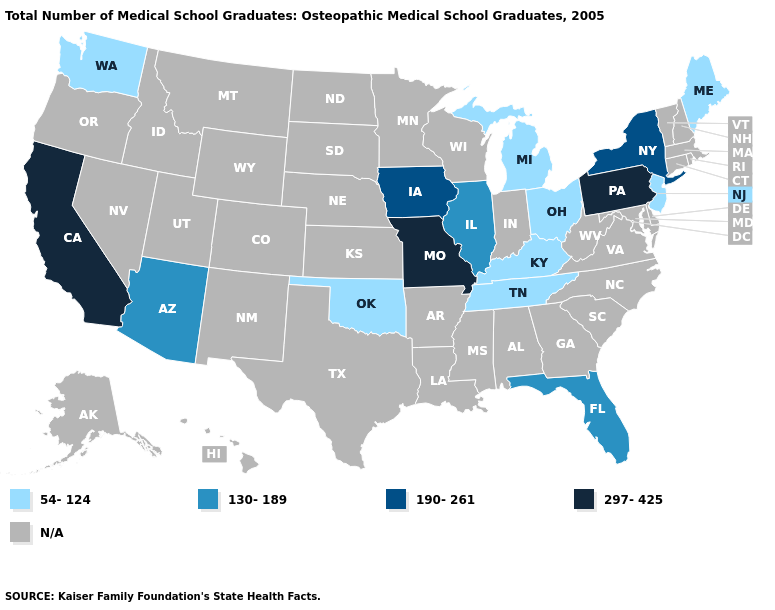Does Maine have the lowest value in the Northeast?
Short answer required. Yes. What is the value of Washington?
Quick response, please. 54-124. What is the value of South Dakota?
Be succinct. N/A. What is the value of Nevada?
Keep it brief. N/A. What is the value of Montana?
Keep it brief. N/A. Is the legend a continuous bar?
Give a very brief answer. No. Name the states that have a value in the range 130-189?
Short answer required. Arizona, Florida, Illinois. Does New York have the highest value in the USA?
Quick response, please. No. Does the first symbol in the legend represent the smallest category?
Write a very short answer. Yes. Name the states that have a value in the range 297-425?
Give a very brief answer. California, Missouri, Pennsylvania. Which states have the highest value in the USA?
Be succinct. California, Missouri, Pennsylvania. What is the value of New York?
Be succinct. 190-261. Name the states that have a value in the range N/A?
Short answer required. Alabama, Alaska, Arkansas, Colorado, Connecticut, Delaware, Georgia, Hawaii, Idaho, Indiana, Kansas, Louisiana, Maryland, Massachusetts, Minnesota, Mississippi, Montana, Nebraska, Nevada, New Hampshire, New Mexico, North Carolina, North Dakota, Oregon, Rhode Island, South Carolina, South Dakota, Texas, Utah, Vermont, Virginia, West Virginia, Wisconsin, Wyoming. 